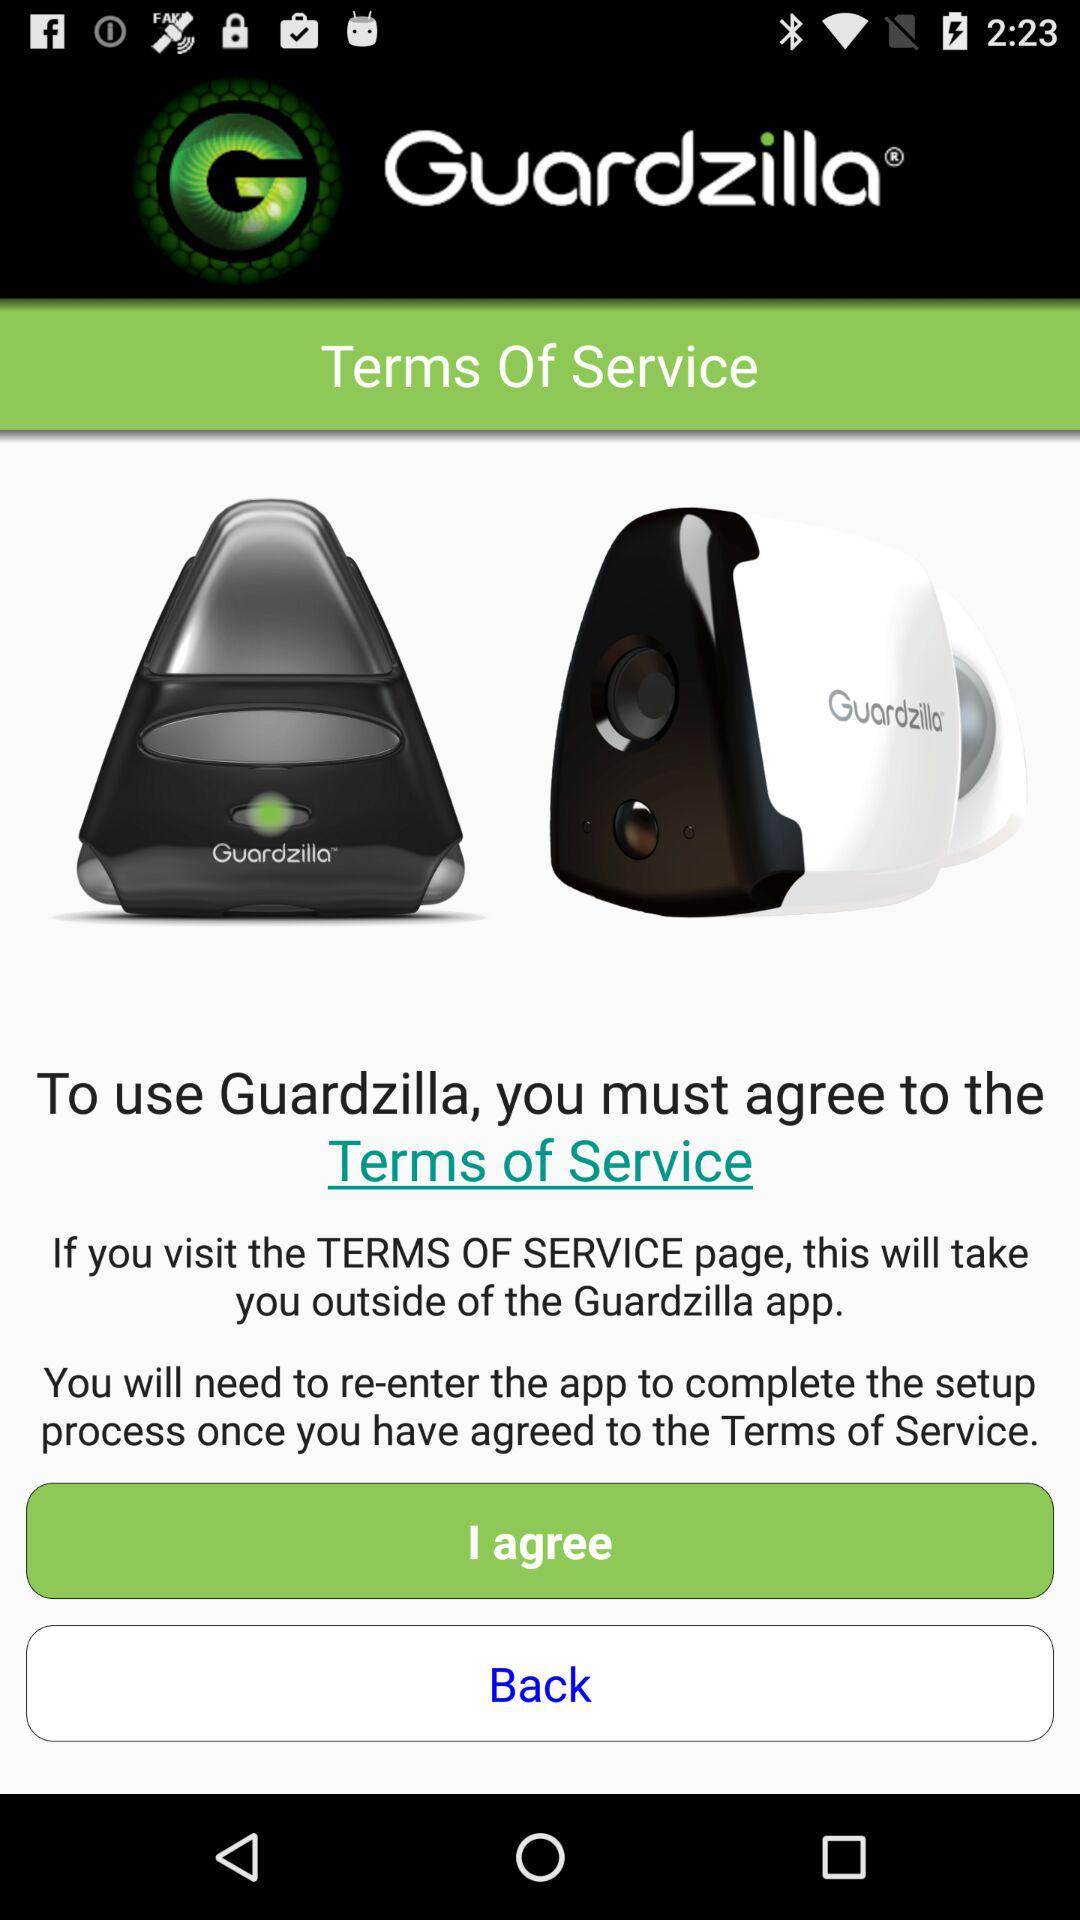What is the name of the application? The name of the application is "Guardzilla". 